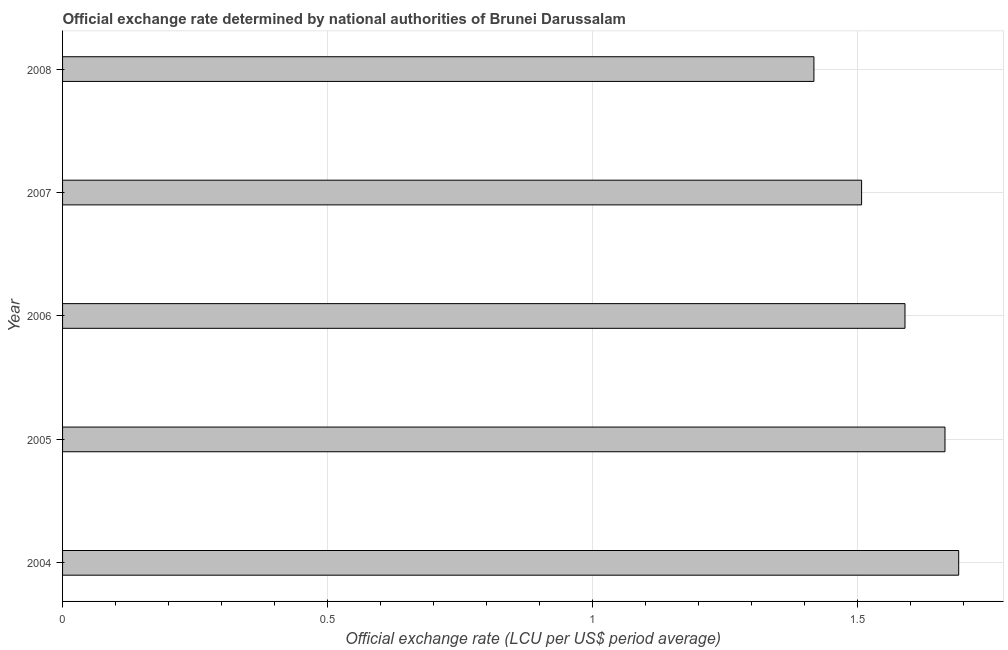What is the title of the graph?
Keep it short and to the point. Official exchange rate determined by national authorities of Brunei Darussalam. What is the label or title of the X-axis?
Keep it short and to the point. Official exchange rate (LCU per US$ period average). What is the label or title of the Y-axis?
Offer a very short reply. Year. What is the official exchange rate in 2005?
Your answer should be compact. 1.66. Across all years, what is the maximum official exchange rate?
Provide a succinct answer. 1.69. Across all years, what is the minimum official exchange rate?
Your answer should be very brief. 1.42. In which year was the official exchange rate maximum?
Ensure brevity in your answer.  2004. In which year was the official exchange rate minimum?
Give a very brief answer. 2008. What is the sum of the official exchange rate?
Give a very brief answer. 7.87. What is the difference between the official exchange rate in 2006 and 2007?
Ensure brevity in your answer.  0.08. What is the average official exchange rate per year?
Ensure brevity in your answer.  1.57. What is the median official exchange rate?
Your response must be concise. 1.59. Do a majority of the years between 2006 and 2004 (inclusive) have official exchange rate greater than 0.8 ?
Offer a very short reply. Yes. What is the ratio of the official exchange rate in 2005 to that in 2006?
Offer a very short reply. 1.05. Is the official exchange rate in 2005 less than that in 2007?
Offer a terse response. No. What is the difference between the highest and the second highest official exchange rate?
Keep it short and to the point. 0.03. What is the difference between the highest and the lowest official exchange rate?
Offer a terse response. 0.27. How many bars are there?
Keep it short and to the point. 5. How many years are there in the graph?
Offer a terse response. 5. What is the difference between two consecutive major ticks on the X-axis?
Make the answer very short. 0.5. Are the values on the major ticks of X-axis written in scientific E-notation?
Offer a very short reply. No. What is the Official exchange rate (LCU per US$ period average) of 2004?
Your answer should be very brief. 1.69. What is the Official exchange rate (LCU per US$ period average) of 2005?
Your answer should be very brief. 1.66. What is the Official exchange rate (LCU per US$ period average) of 2006?
Provide a short and direct response. 1.59. What is the Official exchange rate (LCU per US$ period average) of 2007?
Offer a very short reply. 1.51. What is the Official exchange rate (LCU per US$ period average) of 2008?
Keep it short and to the point. 1.42. What is the difference between the Official exchange rate (LCU per US$ period average) in 2004 and 2005?
Your answer should be compact. 0.03. What is the difference between the Official exchange rate (LCU per US$ period average) in 2004 and 2006?
Your response must be concise. 0.1. What is the difference between the Official exchange rate (LCU per US$ period average) in 2004 and 2007?
Your answer should be compact. 0.18. What is the difference between the Official exchange rate (LCU per US$ period average) in 2004 and 2008?
Your answer should be compact. 0.27. What is the difference between the Official exchange rate (LCU per US$ period average) in 2005 and 2006?
Your answer should be compact. 0.08. What is the difference between the Official exchange rate (LCU per US$ period average) in 2005 and 2007?
Make the answer very short. 0.16. What is the difference between the Official exchange rate (LCU per US$ period average) in 2005 and 2008?
Keep it short and to the point. 0.25. What is the difference between the Official exchange rate (LCU per US$ period average) in 2006 and 2007?
Offer a terse response. 0.08. What is the difference between the Official exchange rate (LCU per US$ period average) in 2006 and 2008?
Provide a succinct answer. 0.17. What is the difference between the Official exchange rate (LCU per US$ period average) in 2007 and 2008?
Your answer should be compact. 0.09. What is the ratio of the Official exchange rate (LCU per US$ period average) in 2004 to that in 2005?
Provide a short and direct response. 1.02. What is the ratio of the Official exchange rate (LCU per US$ period average) in 2004 to that in 2006?
Ensure brevity in your answer.  1.06. What is the ratio of the Official exchange rate (LCU per US$ period average) in 2004 to that in 2007?
Make the answer very short. 1.12. What is the ratio of the Official exchange rate (LCU per US$ period average) in 2004 to that in 2008?
Offer a very short reply. 1.19. What is the ratio of the Official exchange rate (LCU per US$ period average) in 2005 to that in 2006?
Keep it short and to the point. 1.05. What is the ratio of the Official exchange rate (LCU per US$ period average) in 2005 to that in 2007?
Offer a very short reply. 1.1. What is the ratio of the Official exchange rate (LCU per US$ period average) in 2005 to that in 2008?
Offer a terse response. 1.17. What is the ratio of the Official exchange rate (LCU per US$ period average) in 2006 to that in 2007?
Provide a short and direct response. 1.05. What is the ratio of the Official exchange rate (LCU per US$ period average) in 2006 to that in 2008?
Offer a terse response. 1.12. What is the ratio of the Official exchange rate (LCU per US$ period average) in 2007 to that in 2008?
Provide a short and direct response. 1.06. 